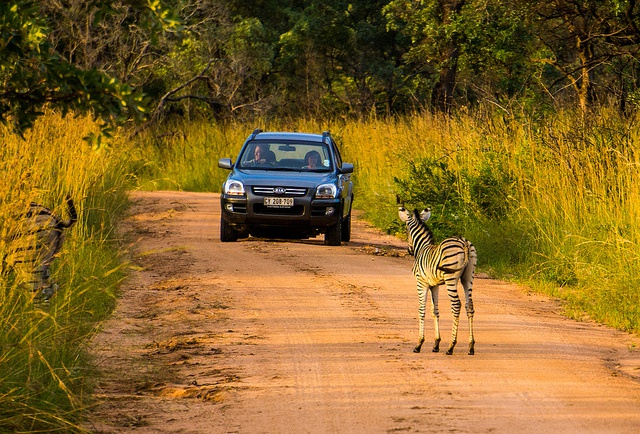Describe the objects in this image and their specific colors. I can see car in black, gray, and blue tones, zebra in black, orange, and olive tones, people in black, blue, gray, and darkblue tones, and people in black, gray, blue, and teal tones in this image. 